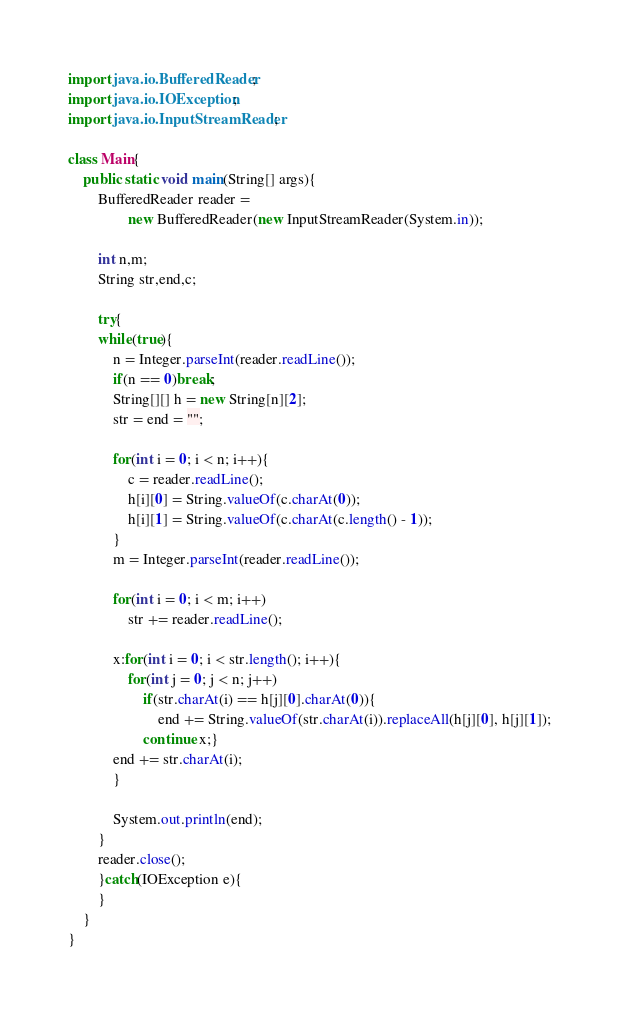<code> <loc_0><loc_0><loc_500><loc_500><_Java_>import java.io.BufferedReader;
import java.io.IOException;
import java.io.InputStreamReader;

class Main{
	public static void main(String[] args){
		BufferedReader reader = 
				new BufferedReader(new InputStreamReader(System.in));
		
		int n,m;
		String str,end,c;
		
		try{
		while(true){
			n = Integer.parseInt(reader.readLine());
			if(n == 0)break;
			String[][] h = new String[n][2];
			str = end = "";
			
			for(int i = 0; i < n; i++){
				c = reader.readLine();
				h[i][0] = String.valueOf(c.charAt(0));
				h[i][1] = String.valueOf(c.charAt(c.length() - 1));
			}
			m = Integer.parseInt(reader.readLine());
			
			for(int i = 0; i < m; i++)
				str += reader.readLine();
			
			x:for(int i = 0; i < str.length(); i++){
				for(int j = 0; j < n; j++)
					if(str.charAt(i) == h[j][0].charAt(0)){
						end += String.valueOf(str.charAt(i)).replaceAll(h[j][0], h[j][1]);
					continue x;}
			end += str.charAt(i);
			}
			
			System.out.println(end);
		}
		reader.close();
		}catch(IOException e){
		}
	}
}</code> 